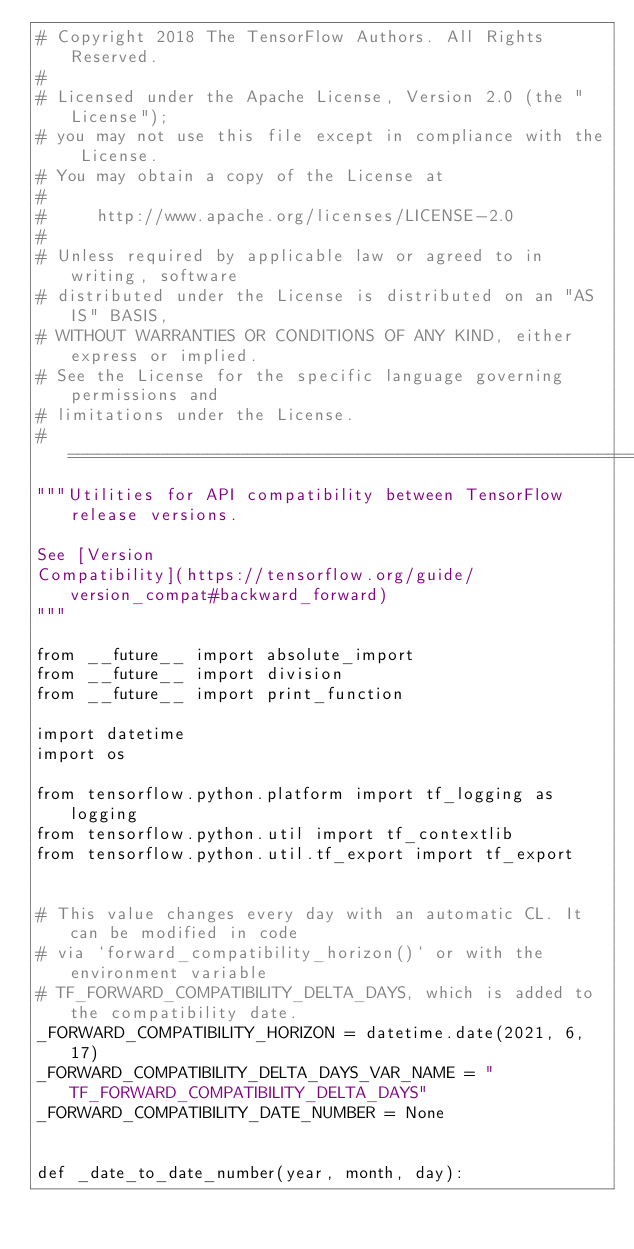Convert code to text. <code><loc_0><loc_0><loc_500><loc_500><_Python_># Copyright 2018 The TensorFlow Authors. All Rights Reserved.
#
# Licensed under the Apache License, Version 2.0 (the "License");
# you may not use this file except in compliance with the License.
# You may obtain a copy of the License at
#
#     http://www.apache.org/licenses/LICENSE-2.0
#
# Unless required by applicable law or agreed to in writing, software
# distributed under the License is distributed on an "AS IS" BASIS,
# WITHOUT WARRANTIES OR CONDITIONS OF ANY KIND, either express or implied.
# See the License for the specific language governing permissions and
# limitations under the License.
# ==============================================================================
"""Utilities for API compatibility between TensorFlow release versions.

See [Version
Compatibility](https://tensorflow.org/guide/version_compat#backward_forward)
"""

from __future__ import absolute_import
from __future__ import division
from __future__ import print_function

import datetime
import os

from tensorflow.python.platform import tf_logging as logging
from tensorflow.python.util import tf_contextlib
from tensorflow.python.util.tf_export import tf_export


# This value changes every day with an automatic CL. It can be modified in code
# via `forward_compatibility_horizon()` or with the environment variable
# TF_FORWARD_COMPATIBILITY_DELTA_DAYS, which is added to the compatibility date.
_FORWARD_COMPATIBILITY_HORIZON = datetime.date(2021, 6, 17)
_FORWARD_COMPATIBILITY_DELTA_DAYS_VAR_NAME = "TF_FORWARD_COMPATIBILITY_DELTA_DAYS"
_FORWARD_COMPATIBILITY_DATE_NUMBER = None


def _date_to_date_number(year, month, day):</code> 